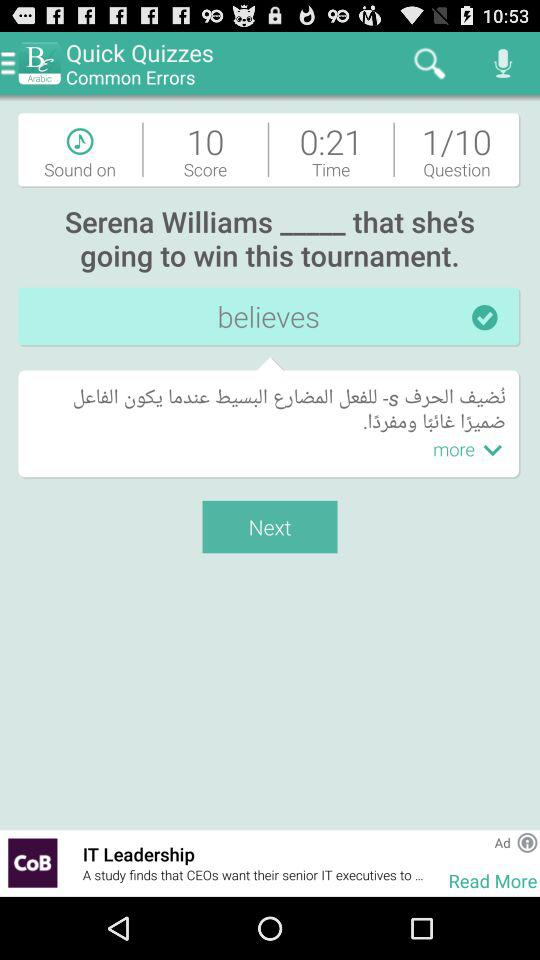How many questions in total are there? There are 10 questions in total. 